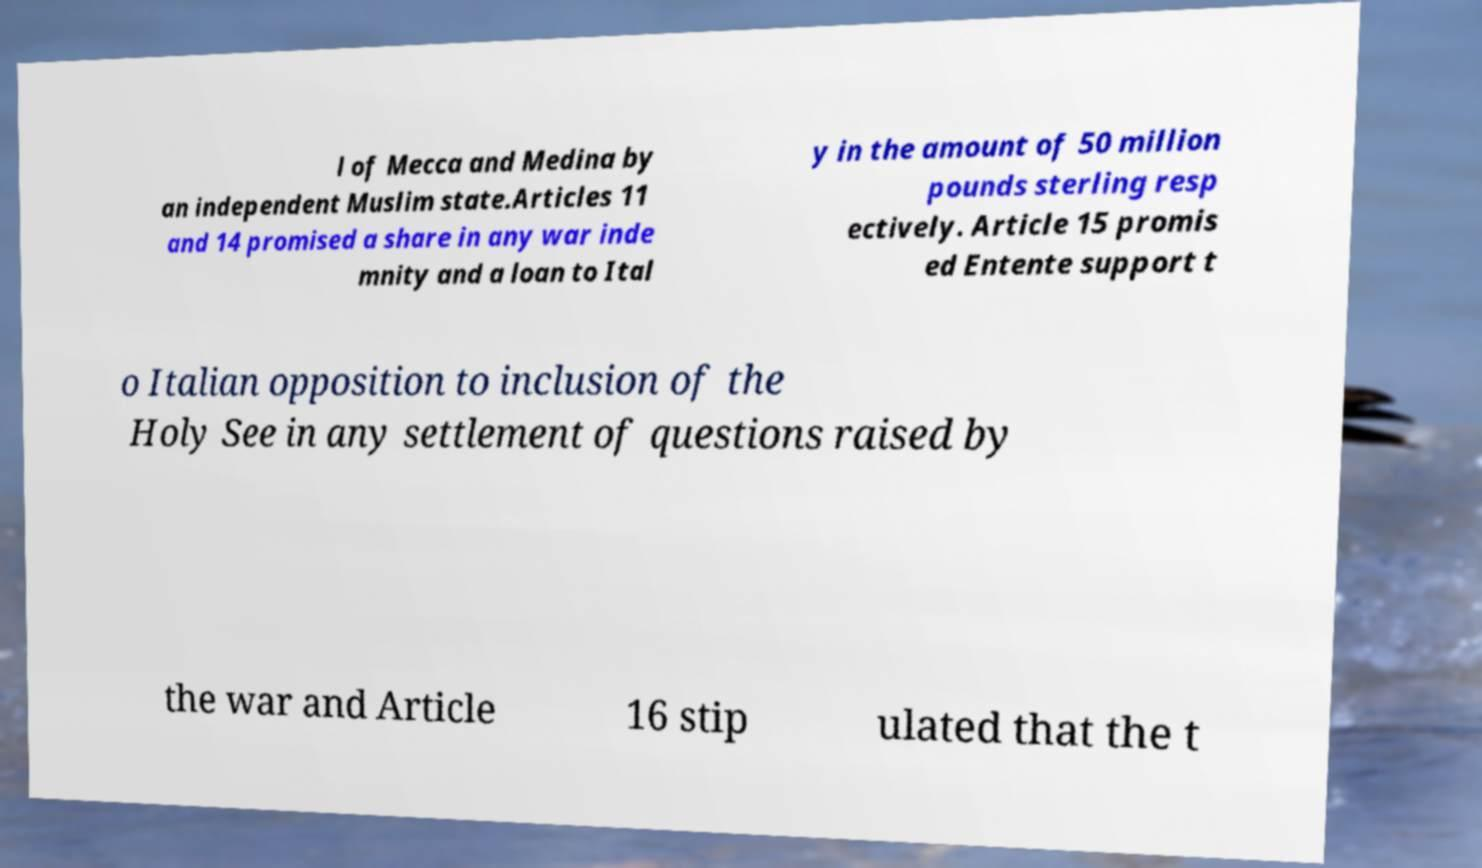Can you accurately transcribe the text from the provided image for me? l of Mecca and Medina by an independent Muslim state.Articles 11 and 14 promised a share in any war inde mnity and a loan to Ital y in the amount of 50 million pounds sterling resp ectively. Article 15 promis ed Entente support t o Italian opposition to inclusion of the Holy See in any settlement of questions raised by the war and Article 16 stip ulated that the t 